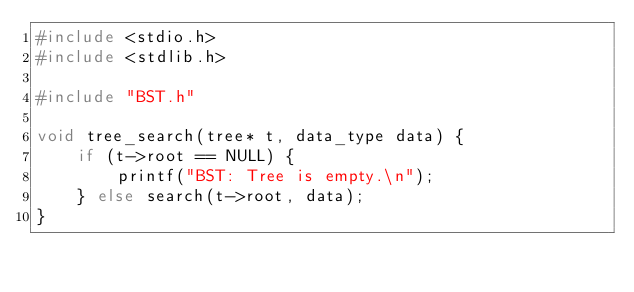Convert code to text. <code><loc_0><loc_0><loc_500><loc_500><_C_>#include <stdio.h>
#include <stdlib.h>

#include "BST.h"

void tree_search(tree* t, data_type data) {
    if (t->root == NULL) {
        printf("BST: Tree is empty.\n");
    } else search(t->root, data);
}</code> 